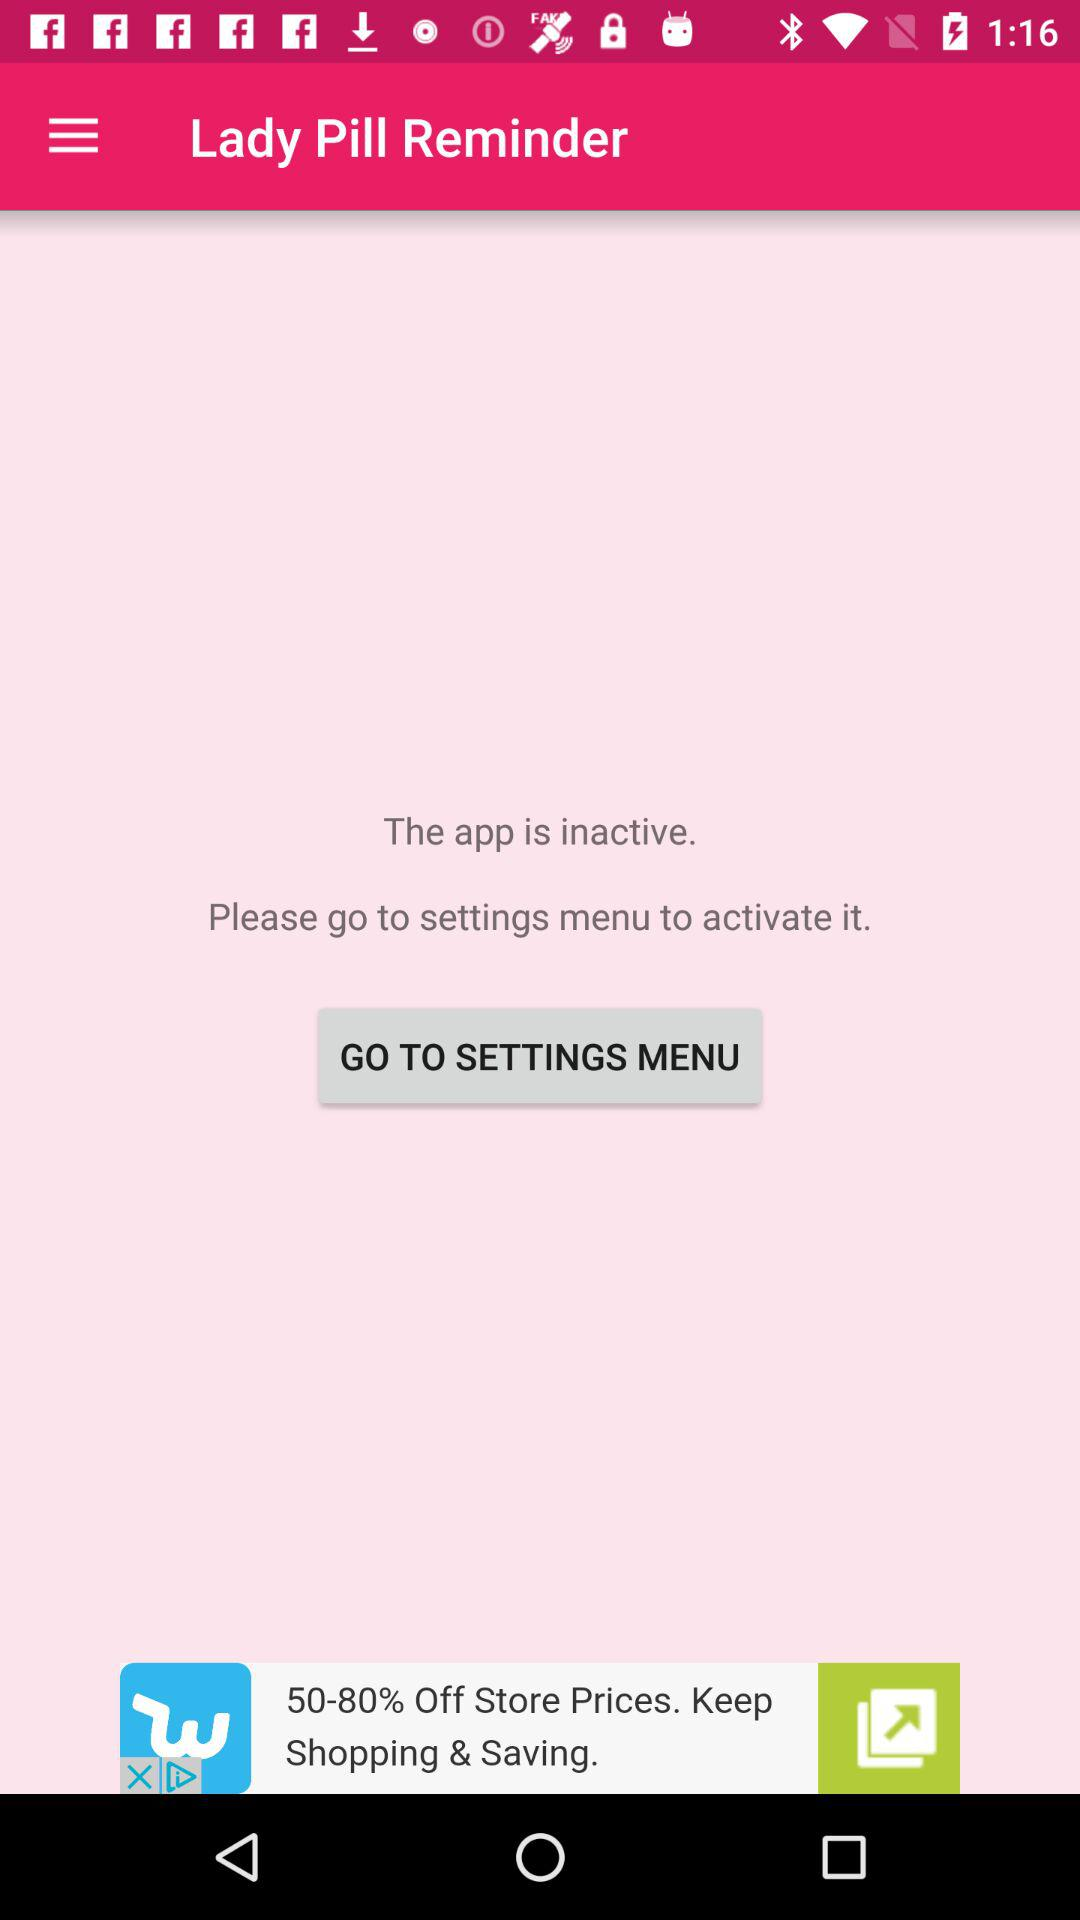What is the current status of the application? The current status of the application is "inactive". 